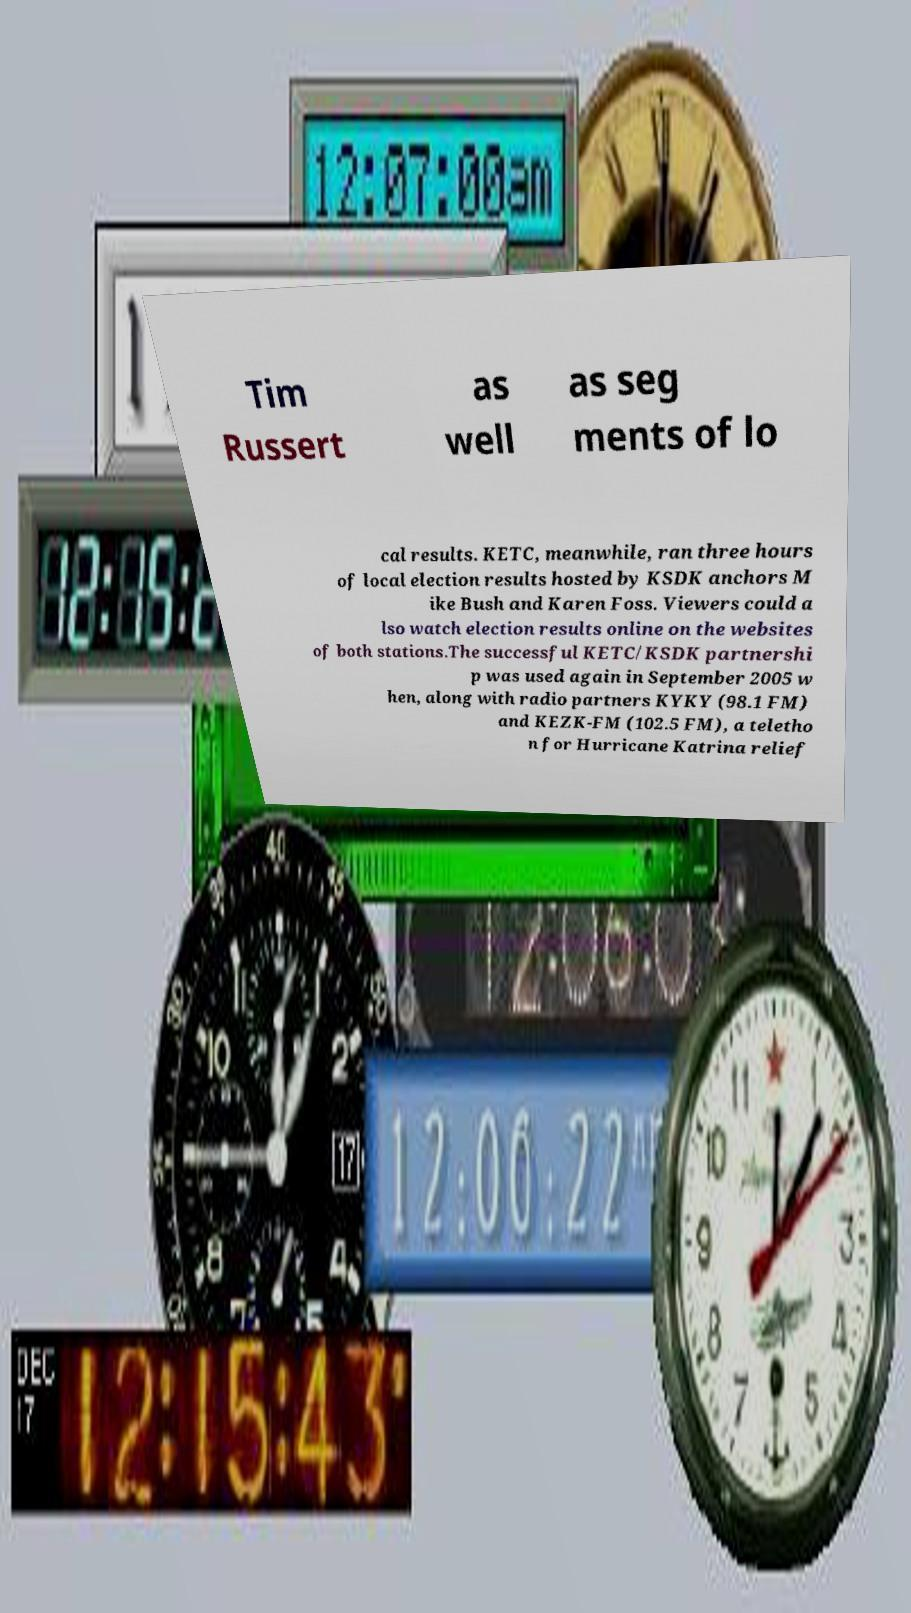Could you assist in decoding the text presented in this image and type it out clearly? Tim Russert as well as seg ments of lo cal results. KETC, meanwhile, ran three hours of local election results hosted by KSDK anchors M ike Bush and Karen Foss. Viewers could a lso watch election results online on the websites of both stations.The successful KETC/KSDK partnershi p was used again in September 2005 w hen, along with radio partners KYKY (98.1 FM) and KEZK-FM (102.5 FM), a teletho n for Hurricane Katrina relief 